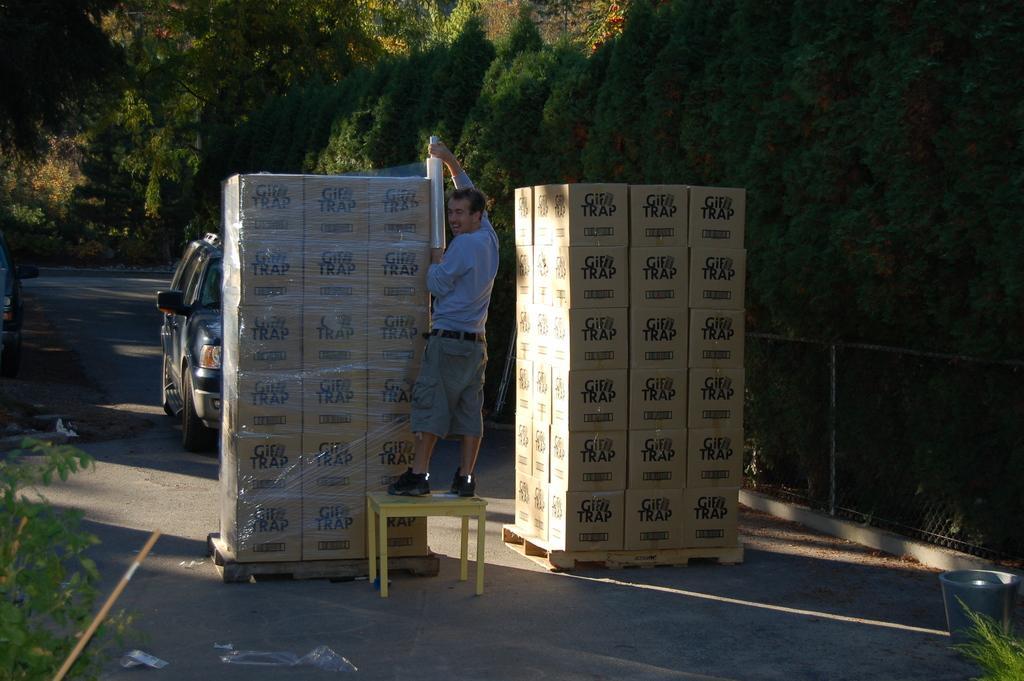In one or two sentences, can you explain what this image depicts? In this picture we can see a person holding an object in his hand. There are few boxes on the path. We can see a dustbin and some fencing on the right side. Few trees are visible in the background. 